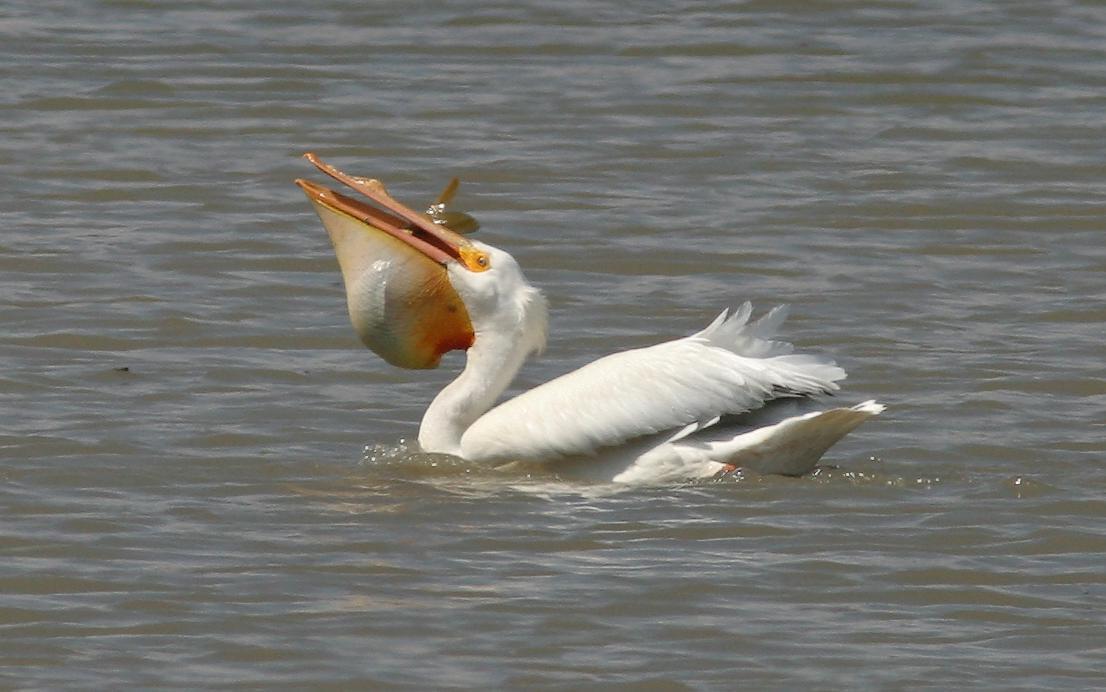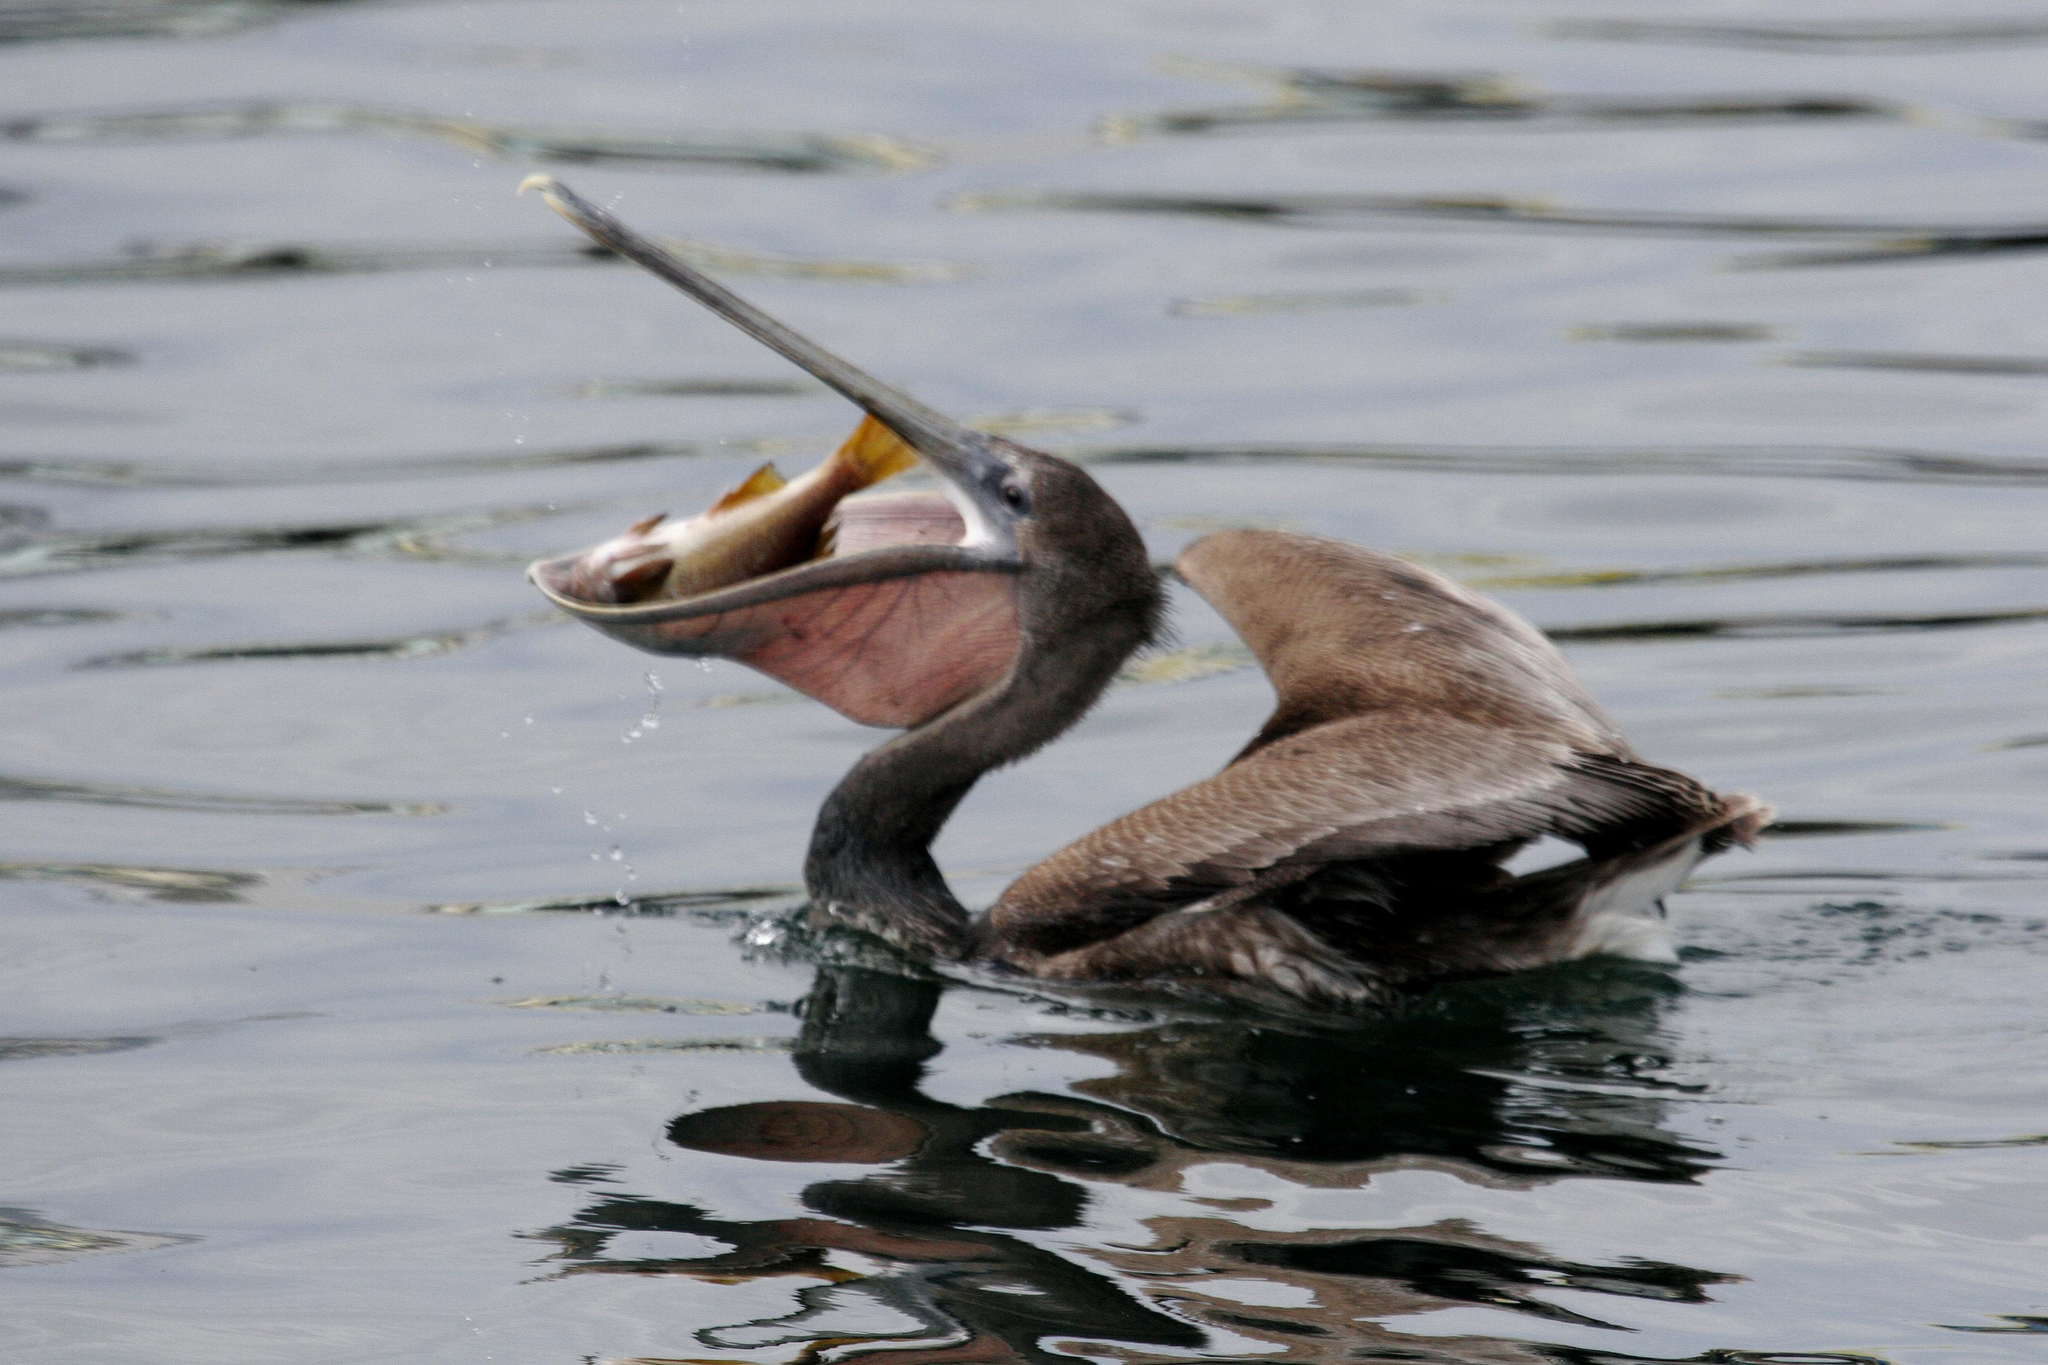The first image is the image on the left, the second image is the image on the right. Considering the images on both sides, is "An image shows a left-facing dark pelican that has a fish in its bill." valid? Answer yes or no. Yes. 